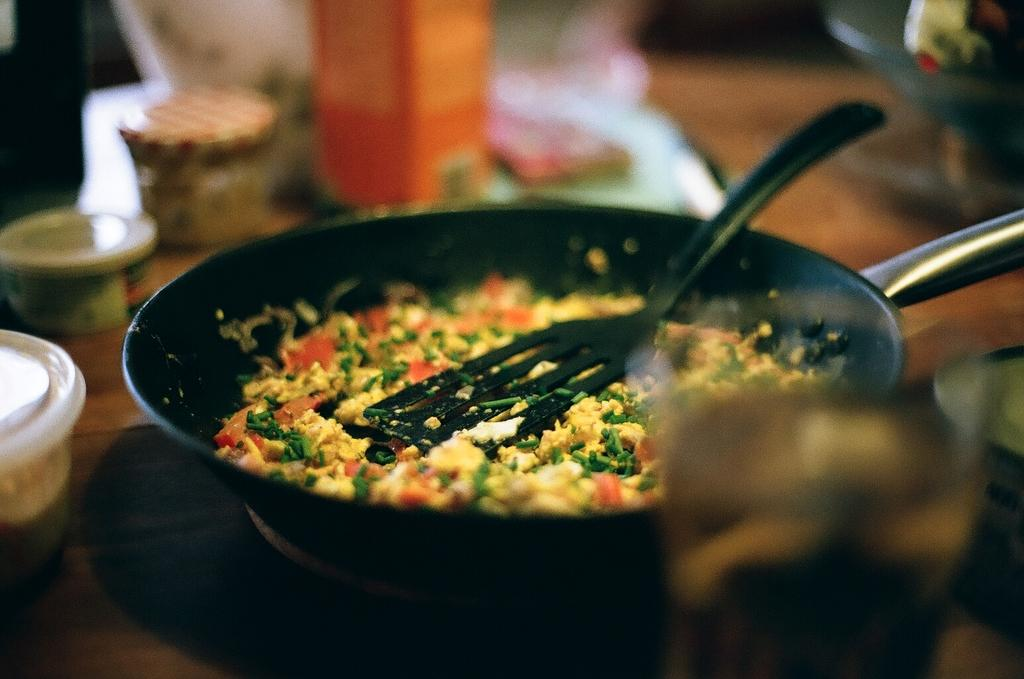What is present in the image that people typically consume? There is food in the image. What is the container used for in the image? There is a container in the image. What type of surface can be seen in the image? There are objects on a wooden surface in the image. What type of train can be seen passing by in the image? There is no train present in the image. What type of glass is being used to serve the food in the image? There is no glass visible in the image; only a container is mentioned. 